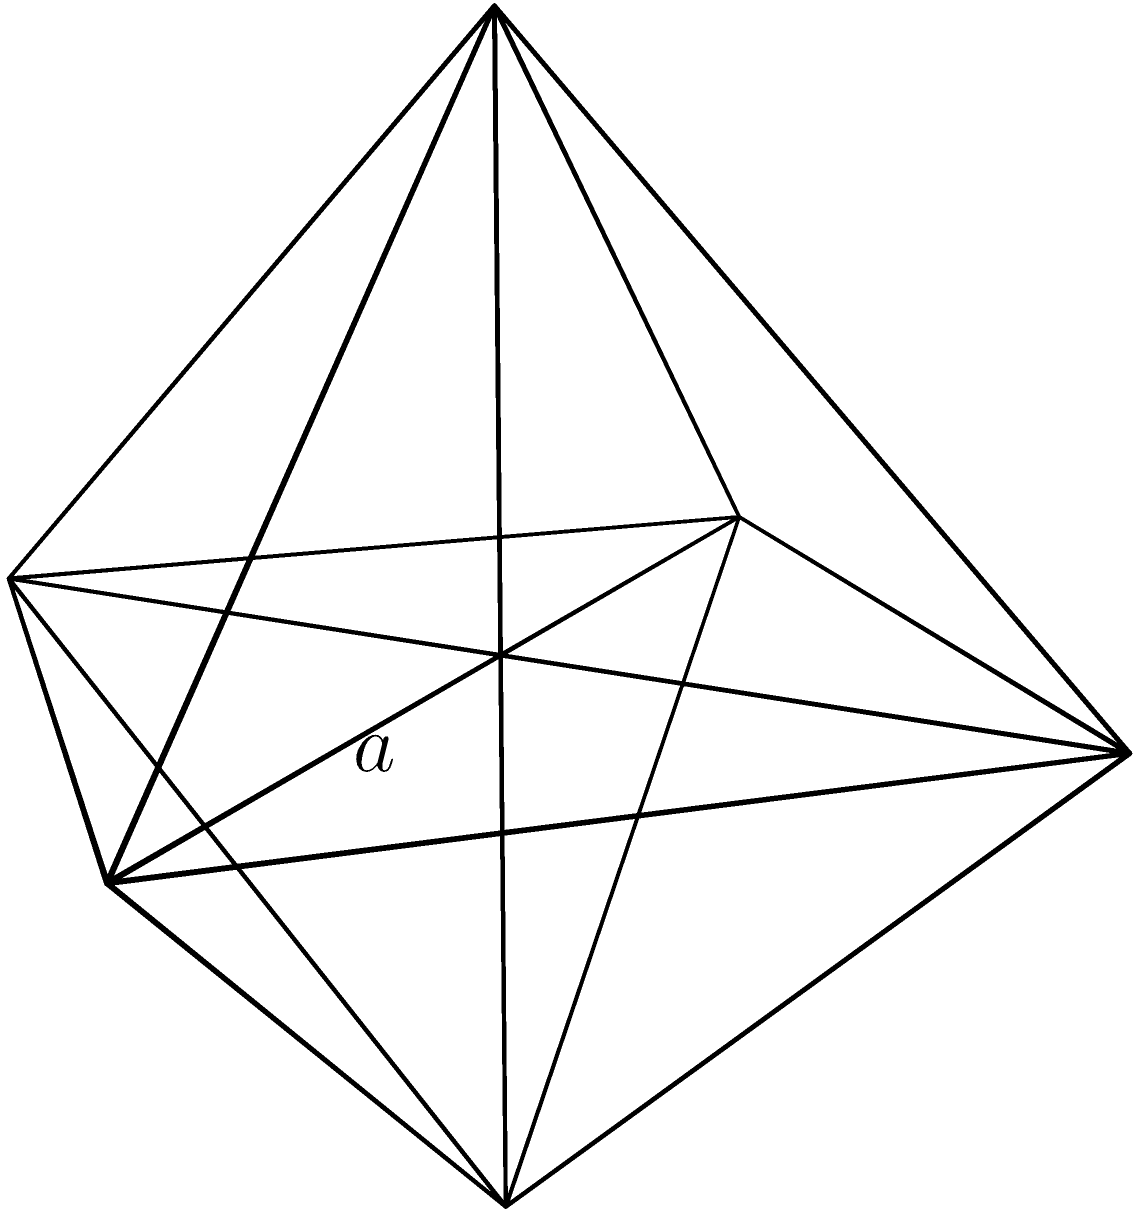As a visual artist exploring the symmetry in solid geometry, you encounter a regular octahedron. Given that each edge of this octahedron has a length of $a = 2$ units, calculate its total surface area. How might this geometric form and its numerical properties inspire your next artwork? Let's approach this step-by-step:

1) A regular octahedron consists of 8 congruent equilateral triangles.

2) To find the surface area, we need to calculate the area of one triangle and multiply it by 8.

3) The area of an equilateral triangle with side length $a$ is given by the formula:

   $$A_{triangle} = \frac{\sqrt{3}}{4}a^2$$

4) Substituting $a = 2$:

   $$A_{triangle} = \frac{\sqrt{3}}{4}(2)^2 = \sqrt{3}$$

5) The total surface area is 8 times this value:

   $$A_{total} = 8 \times \sqrt{3} = 8\sqrt{3}$$

6) Therefore, the total surface area of the octahedron is $8\sqrt{3}$ square units.

This result showcases a beautiful interplay between the number 8 (faces), 2 (edge length), and $\sqrt{3}$ (from the equilateral triangle formula), creating a harmonious pattern that could be incorporated into an artistic piece.
Answer: $8\sqrt{3}$ square units 